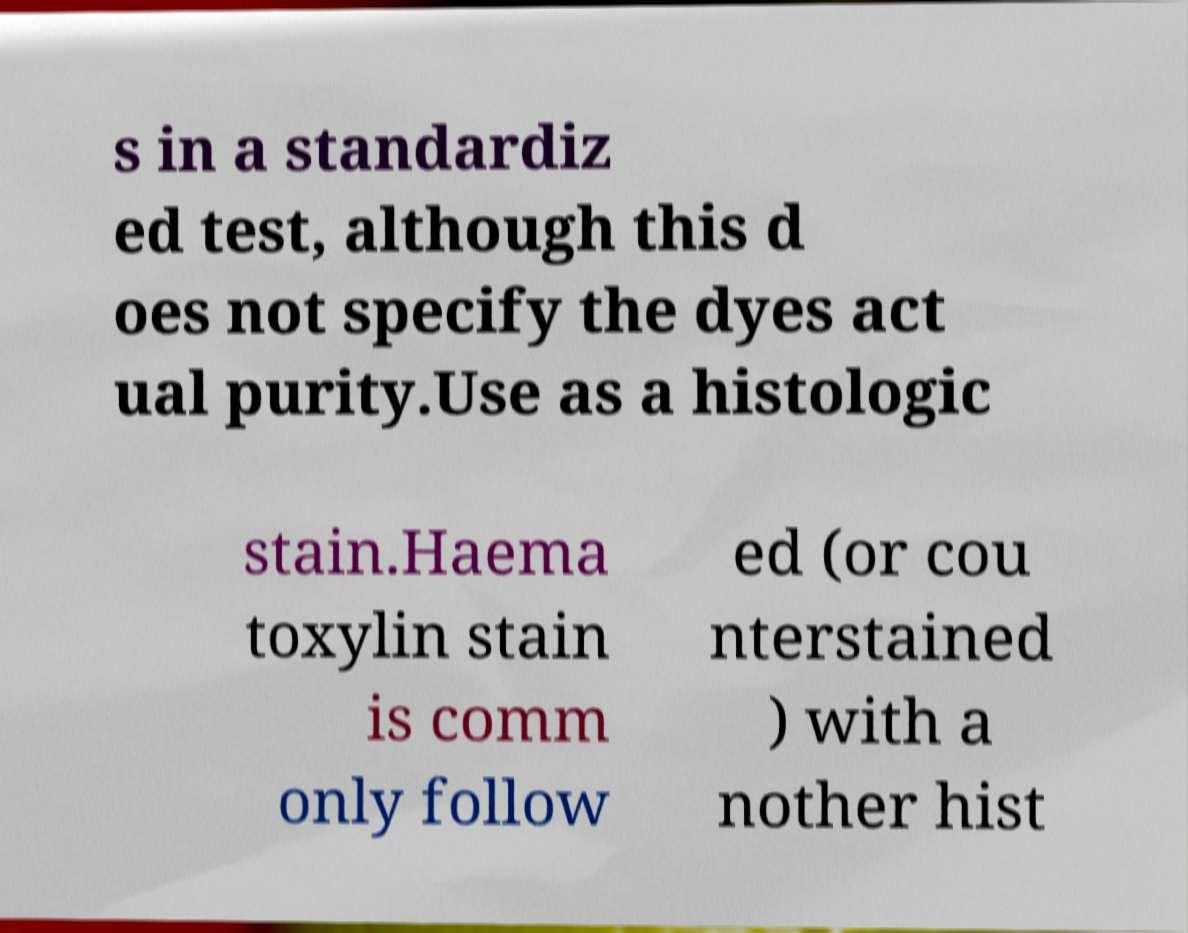For documentation purposes, I need the text within this image transcribed. Could you provide that? s in a standardiz ed test, although this d oes not specify the dyes act ual purity.Use as a histologic stain.Haema toxylin stain is comm only follow ed (or cou nterstained ) with a nother hist 